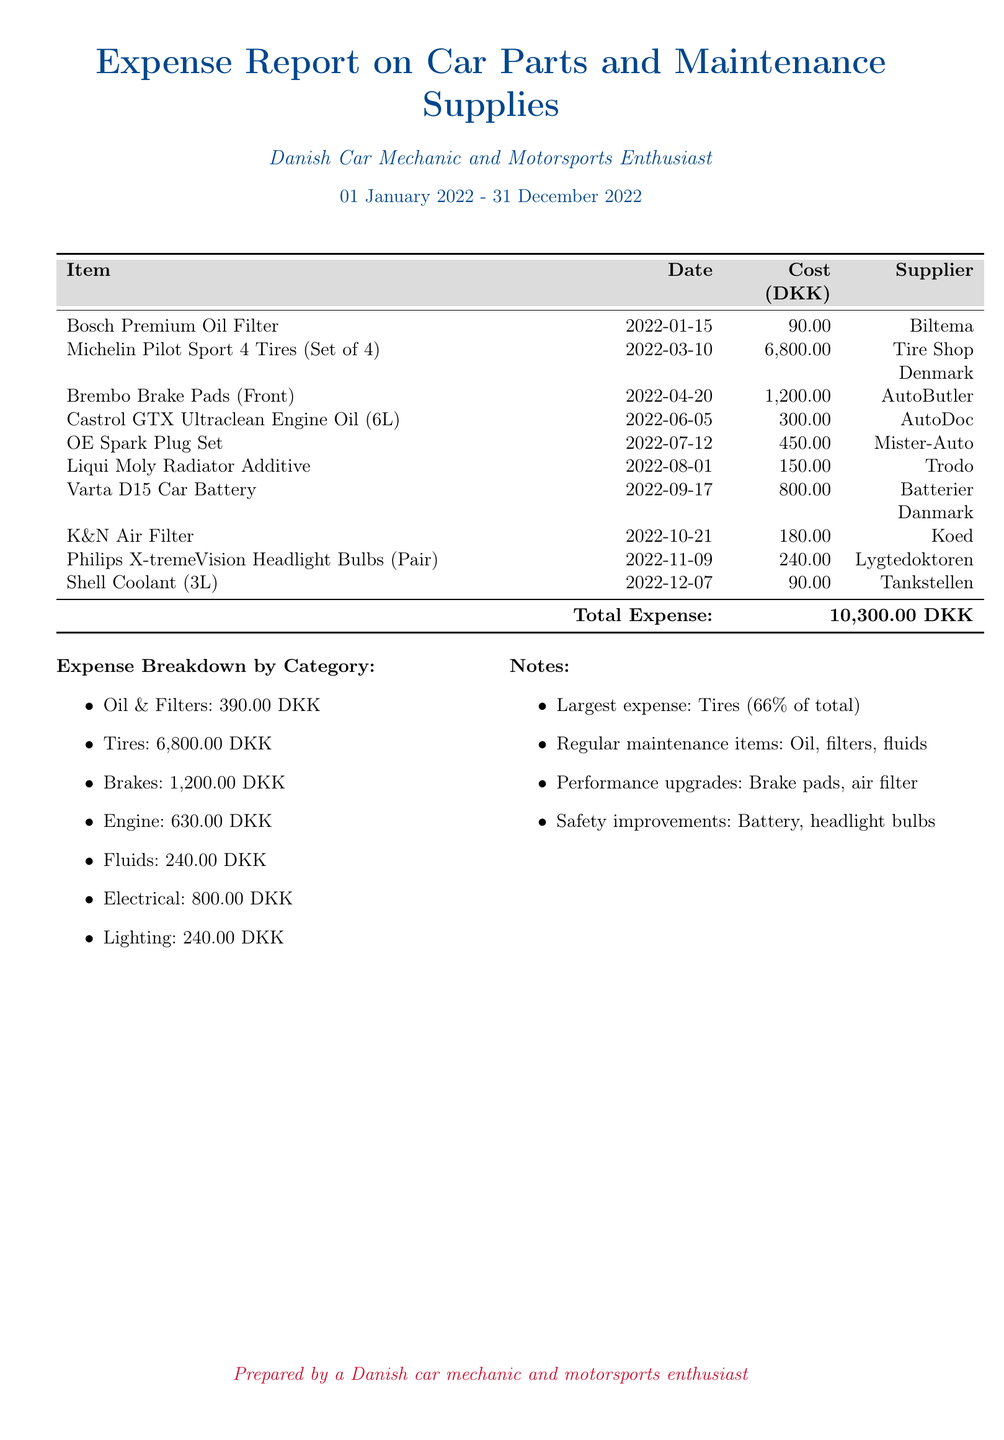What is the total expense? The total expense is provided at the bottom of the expense report, summing all costs listed.
Answer: 10,300.00 DKK Which item cost the most? By reviewing the costs, the highest single item expense can be identified.
Answer: Michelin Pilot Sport 4 Tires (Set of 4) When was the Varta D15 Car Battery purchased? The purchase date of the Varta D15 Car Battery can be found in the document next to the item.
Answer: 2022-09-17 How much was spent on Oil & Filters? The breakdown by category lists expenses for Oil & Filters, which can be extracted from that section.
Answer: 390.00 DKK Which supplier provided the Brembo Brake Pads? The supplier's information is presented alongside the item in the document.
Answer: AutoButler What percentage of the total expense does the tire purchase represent? The percentage can be calculated based on the total expense mentioned and the tire cost.
Answer: 66% How many unique suppliers are listed in the report? The distinct suppliers can be counted from the supplier column in the expense table.
Answer: 7 What is the cost of the Philips X-tremeVision Headlight Bulbs? The specific cost for the Philips X-tremeVision Headlight Bulbs is directly mentioned in the table.
Answer: 240.00 DKK What is listed as a safety improvement in the notes? The notes section mentions specific items considered safety improvements, which can be quoted.
Answer: Battery, headlight bulbs 